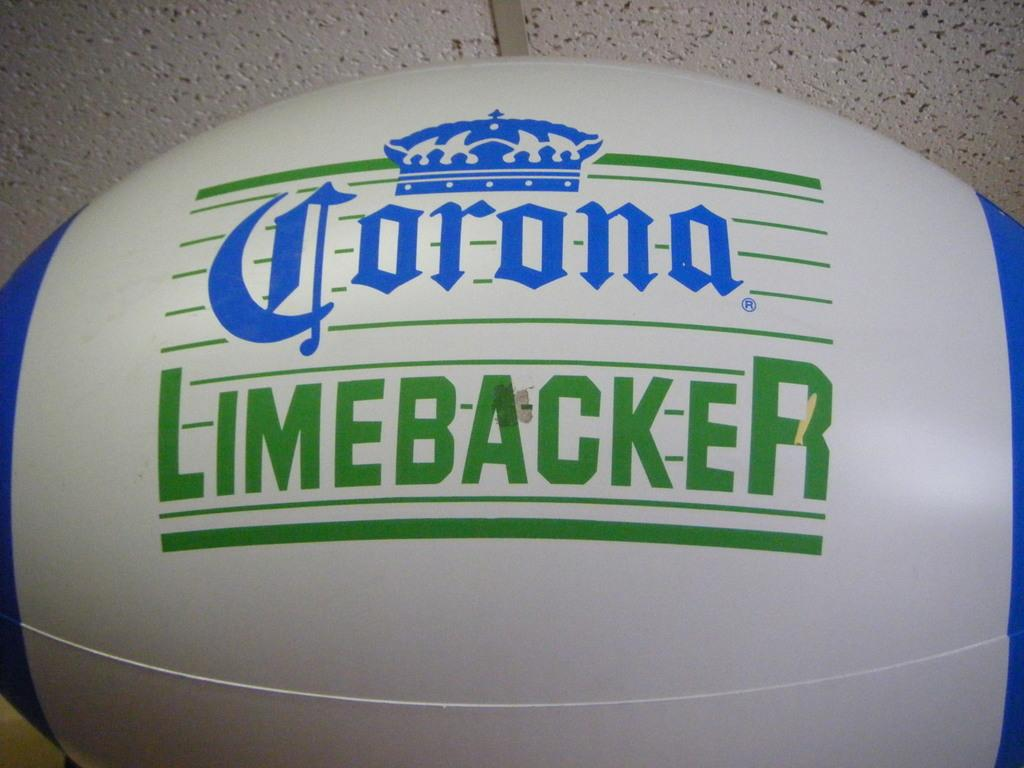What object is the main subject of the picture? There is a ball in the picture. What colors can be seen on the ball? The ball is white and blue in color. What is written on the ball? The name "corona linebacker" is written on the ball. What can be seen in the background of the image? There is a wall in the background of the image. What color is the wall? The wall is white in color. Are there any distinguishing features on the wall? Yes, the wall has a dot on it. What type of hook is hanging from the wall in the image? There is no hook present in the image; only a ball and a wall with a dot are visible. What year is the library mentioned on the ball? There is no mention of a library on the ball, only the name "corona linebacker." 